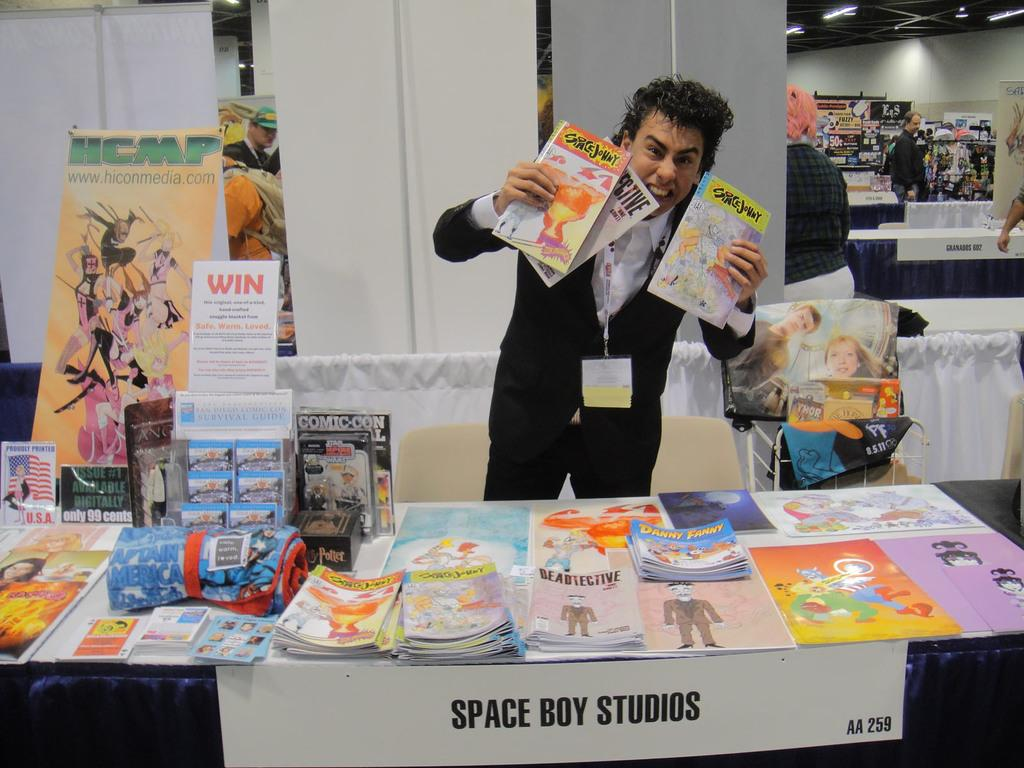<image>
Write a terse but informative summary of the picture. A representative holds up some of the product created by company called Space Boy Studios. 